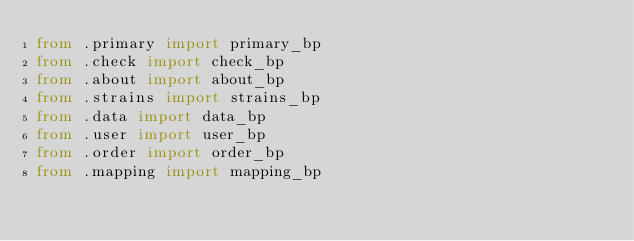Convert code to text. <code><loc_0><loc_0><loc_500><loc_500><_Python_>from .primary import primary_bp
from .check import check_bp
from .about import about_bp
from .strains import strains_bp
from .data import data_bp
from .user import user_bp
from .order import order_bp
from .mapping import mapping_bp</code> 